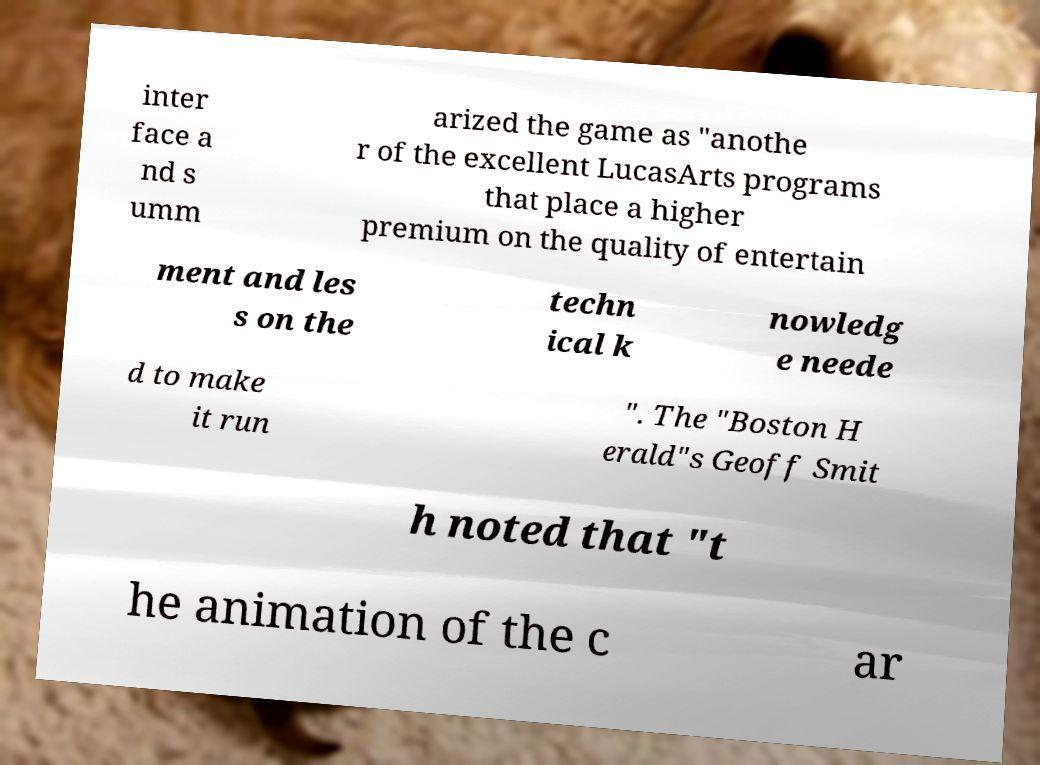There's text embedded in this image that I need extracted. Can you transcribe it verbatim? inter face a nd s umm arized the game as "anothe r of the excellent LucasArts programs that place a higher premium on the quality of entertain ment and les s on the techn ical k nowledg e neede d to make it run ". The "Boston H erald"s Geoff Smit h noted that "t he animation of the c ar 